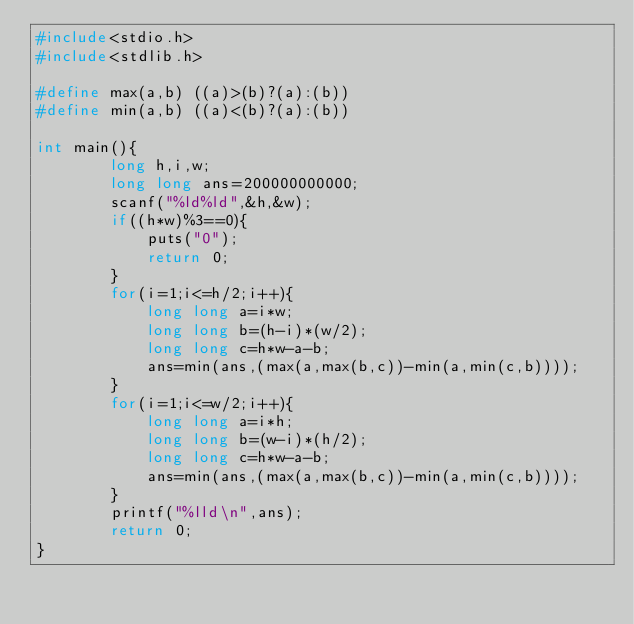<code> <loc_0><loc_0><loc_500><loc_500><_C_>#include<stdio.h>
#include<stdlib.h>

#define max(a,b) ((a)>(b)?(a):(b))
#define min(a,b) ((a)<(b)?(a):(b))

int main(){
		long h,i,w;
		long long ans=200000000000;
		scanf("%ld%ld",&h,&w);
		if((h*w)%3==0){
			puts("0");
			return 0;
		}
		for(i=1;i<=h/2;i++){
			long long a=i*w;
			long long b=(h-i)*(w/2);
			long long c=h*w-a-b;
			ans=min(ans,(max(a,max(b,c))-min(a,min(c,b))));
		}
		for(i=1;i<=w/2;i++){
			long long a=i*h;
			long long b=(w-i)*(h/2);
			long long c=h*w-a-b;
			ans=min(ans,(max(a,max(b,c))-min(a,min(c,b))));
		}
		printf("%lld\n",ans);
		return 0;
}
</code> 